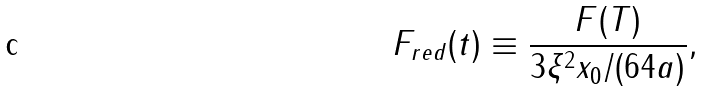Convert formula to latex. <formula><loc_0><loc_0><loc_500><loc_500>F _ { r e d } ( t ) \equiv \frac { F ( T ) } { 3 \xi ^ { 2 } x _ { 0 } / ( 6 4 a ) } ,</formula> 